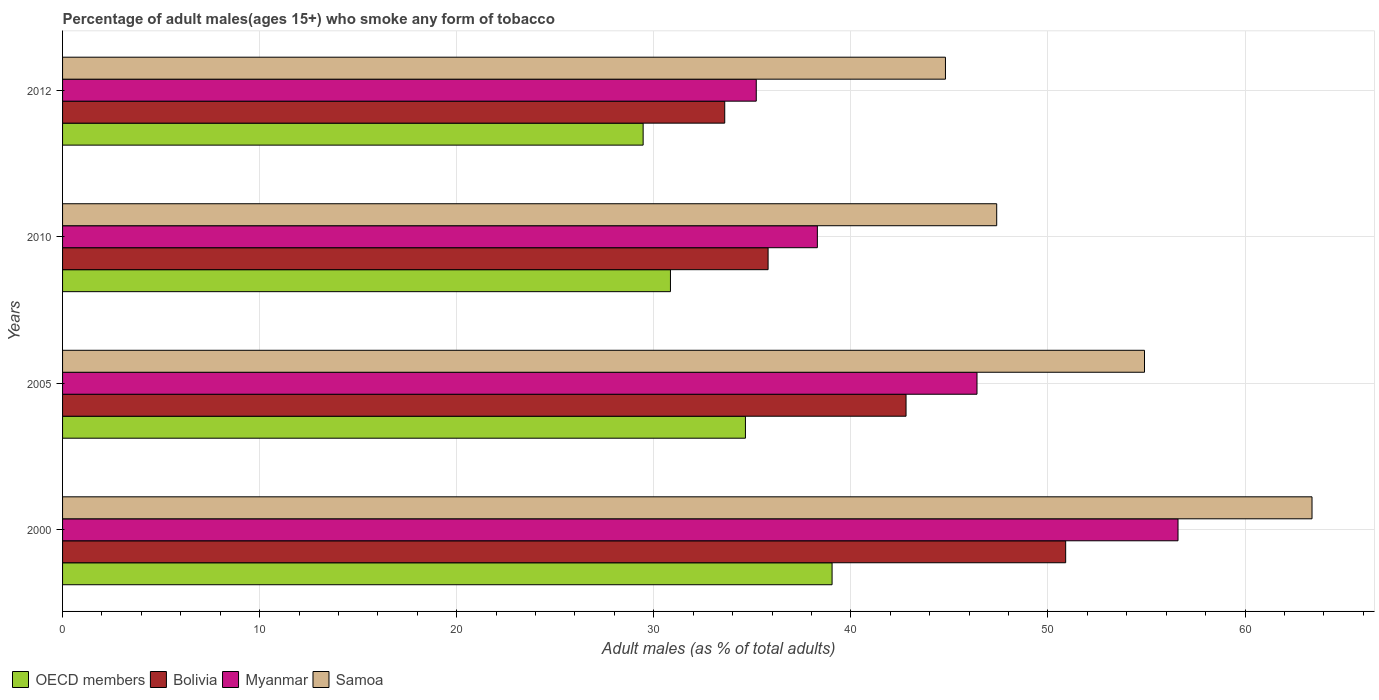Are the number of bars per tick equal to the number of legend labels?
Provide a succinct answer. Yes. Are the number of bars on each tick of the Y-axis equal?
Provide a succinct answer. Yes. How many bars are there on the 4th tick from the bottom?
Your answer should be very brief. 4. What is the label of the 1st group of bars from the top?
Make the answer very short. 2012. What is the percentage of adult males who smoke in OECD members in 2012?
Your answer should be very brief. 29.46. Across all years, what is the maximum percentage of adult males who smoke in Bolivia?
Make the answer very short. 50.9. Across all years, what is the minimum percentage of adult males who smoke in Samoa?
Make the answer very short. 44.8. In which year was the percentage of adult males who smoke in Myanmar maximum?
Offer a terse response. 2000. What is the total percentage of adult males who smoke in Samoa in the graph?
Offer a terse response. 210.5. What is the difference between the percentage of adult males who smoke in Myanmar in 2000 and that in 2005?
Keep it short and to the point. 10.2. What is the difference between the percentage of adult males who smoke in OECD members in 2010 and the percentage of adult males who smoke in Myanmar in 2012?
Your answer should be very brief. -4.35. What is the average percentage of adult males who smoke in OECD members per year?
Your answer should be compact. 33.5. In the year 2012, what is the difference between the percentage of adult males who smoke in OECD members and percentage of adult males who smoke in Myanmar?
Offer a terse response. -5.74. What is the ratio of the percentage of adult males who smoke in Bolivia in 2000 to that in 2010?
Provide a succinct answer. 1.42. Is the difference between the percentage of adult males who smoke in OECD members in 2000 and 2010 greater than the difference between the percentage of adult males who smoke in Myanmar in 2000 and 2010?
Give a very brief answer. No. What is the difference between the highest and the second highest percentage of adult males who smoke in Myanmar?
Make the answer very short. 10.2. What is the difference between the highest and the lowest percentage of adult males who smoke in OECD members?
Provide a short and direct response. 9.59. Is the sum of the percentage of adult males who smoke in Samoa in 2000 and 2005 greater than the maximum percentage of adult males who smoke in Myanmar across all years?
Provide a short and direct response. Yes. What does the 3rd bar from the top in 2012 represents?
Your answer should be very brief. Bolivia. What does the 3rd bar from the bottom in 2000 represents?
Keep it short and to the point. Myanmar. Are all the bars in the graph horizontal?
Make the answer very short. Yes. How many years are there in the graph?
Provide a short and direct response. 4. What is the difference between two consecutive major ticks on the X-axis?
Make the answer very short. 10. Does the graph contain any zero values?
Give a very brief answer. No. Where does the legend appear in the graph?
Your answer should be compact. Bottom left. How many legend labels are there?
Make the answer very short. 4. What is the title of the graph?
Ensure brevity in your answer.  Percentage of adult males(ages 15+) who smoke any form of tobacco. What is the label or title of the X-axis?
Keep it short and to the point. Adult males (as % of total adults). What is the Adult males (as % of total adults) in OECD members in 2000?
Your response must be concise. 39.05. What is the Adult males (as % of total adults) of Bolivia in 2000?
Your response must be concise. 50.9. What is the Adult males (as % of total adults) in Myanmar in 2000?
Your answer should be very brief. 56.6. What is the Adult males (as % of total adults) in Samoa in 2000?
Your answer should be very brief. 63.4. What is the Adult males (as % of total adults) of OECD members in 2005?
Make the answer very short. 34.65. What is the Adult males (as % of total adults) in Bolivia in 2005?
Keep it short and to the point. 42.8. What is the Adult males (as % of total adults) of Myanmar in 2005?
Provide a succinct answer. 46.4. What is the Adult males (as % of total adults) in Samoa in 2005?
Ensure brevity in your answer.  54.9. What is the Adult males (as % of total adults) in OECD members in 2010?
Your answer should be compact. 30.85. What is the Adult males (as % of total adults) in Bolivia in 2010?
Your answer should be compact. 35.8. What is the Adult males (as % of total adults) of Myanmar in 2010?
Your answer should be very brief. 38.3. What is the Adult males (as % of total adults) in Samoa in 2010?
Your answer should be very brief. 47.4. What is the Adult males (as % of total adults) in OECD members in 2012?
Your answer should be compact. 29.46. What is the Adult males (as % of total adults) of Bolivia in 2012?
Your response must be concise. 33.6. What is the Adult males (as % of total adults) of Myanmar in 2012?
Provide a short and direct response. 35.2. What is the Adult males (as % of total adults) in Samoa in 2012?
Make the answer very short. 44.8. Across all years, what is the maximum Adult males (as % of total adults) in OECD members?
Your answer should be compact. 39.05. Across all years, what is the maximum Adult males (as % of total adults) of Bolivia?
Offer a very short reply. 50.9. Across all years, what is the maximum Adult males (as % of total adults) of Myanmar?
Keep it short and to the point. 56.6. Across all years, what is the maximum Adult males (as % of total adults) in Samoa?
Ensure brevity in your answer.  63.4. Across all years, what is the minimum Adult males (as % of total adults) of OECD members?
Offer a terse response. 29.46. Across all years, what is the minimum Adult males (as % of total adults) in Bolivia?
Offer a very short reply. 33.6. Across all years, what is the minimum Adult males (as % of total adults) of Myanmar?
Your answer should be compact. 35.2. Across all years, what is the minimum Adult males (as % of total adults) in Samoa?
Your answer should be very brief. 44.8. What is the total Adult males (as % of total adults) in OECD members in the graph?
Provide a short and direct response. 134. What is the total Adult males (as % of total adults) of Bolivia in the graph?
Offer a terse response. 163.1. What is the total Adult males (as % of total adults) in Myanmar in the graph?
Provide a short and direct response. 176.5. What is the total Adult males (as % of total adults) in Samoa in the graph?
Your answer should be very brief. 210.5. What is the difference between the Adult males (as % of total adults) in OECD members in 2000 and that in 2005?
Provide a short and direct response. 4.4. What is the difference between the Adult males (as % of total adults) of Myanmar in 2000 and that in 2005?
Ensure brevity in your answer.  10.2. What is the difference between the Adult males (as % of total adults) in OECD members in 2000 and that in 2010?
Offer a very short reply. 8.2. What is the difference between the Adult males (as % of total adults) in Bolivia in 2000 and that in 2010?
Provide a short and direct response. 15.1. What is the difference between the Adult males (as % of total adults) in Samoa in 2000 and that in 2010?
Provide a short and direct response. 16. What is the difference between the Adult males (as % of total adults) of OECD members in 2000 and that in 2012?
Keep it short and to the point. 9.59. What is the difference between the Adult males (as % of total adults) of Bolivia in 2000 and that in 2012?
Keep it short and to the point. 17.3. What is the difference between the Adult males (as % of total adults) in Myanmar in 2000 and that in 2012?
Your answer should be compact. 21.4. What is the difference between the Adult males (as % of total adults) of Samoa in 2000 and that in 2012?
Ensure brevity in your answer.  18.6. What is the difference between the Adult males (as % of total adults) of OECD members in 2005 and that in 2010?
Ensure brevity in your answer.  3.81. What is the difference between the Adult males (as % of total adults) of Myanmar in 2005 and that in 2010?
Make the answer very short. 8.1. What is the difference between the Adult males (as % of total adults) in Samoa in 2005 and that in 2010?
Offer a very short reply. 7.5. What is the difference between the Adult males (as % of total adults) of OECD members in 2005 and that in 2012?
Your answer should be compact. 5.19. What is the difference between the Adult males (as % of total adults) of Bolivia in 2005 and that in 2012?
Your response must be concise. 9.2. What is the difference between the Adult males (as % of total adults) in Samoa in 2005 and that in 2012?
Make the answer very short. 10.1. What is the difference between the Adult males (as % of total adults) of OECD members in 2010 and that in 2012?
Offer a terse response. 1.39. What is the difference between the Adult males (as % of total adults) of Samoa in 2010 and that in 2012?
Make the answer very short. 2.6. What is the difference between the Adult males (as % of total adults) of OECD members in 2000 and the Adult males (as % of total adults) of Bolivia in 2005?
Offer a very short reply. -3.75. What is the difference between the Adult males (as % of total adults) of OECD members in 2000 and the Adult males (as % of total adults) of Myanmar in 2005?
Make the answer very short. -7.35. What is the difference between the Adult males (as % of total adults) in OECD members in 2000 and the Adult males (as % of total adults) in Samoa in 2005?
Provide a short and direct response. -15.85. What is the difference between the Adult males (as % of total adults) of Bolivia in 2000 and the Adult males (as % of total adults) of Myanmar in 2005?
Offer a very short reply. 4.5. What is the difference between the Adult males (as % of total adults) in Myanmar in 2000 and the Adult males (as % of total adults) in Samoa in 2005?
Ensure brevity in your answer.  1.7. What is the difference between the Adult males (as % of total adults) in OECD members in 2000 and the Adult males (as % of total adults) in Bolivia in 2010?
Provide a short and direct response. 3.25. What is the difference between the Adult males (as % of total adults) in OECD members in 2000 and the Adult males (as % of total adults) in Myanmar in 2010?
Make the answer very short. 0.75. What is the difference between the Adult males (as % of total adults) of OECD members in 2000 and the Adult males (as % of total adults) of Samoa in 2010?
Keep it short and to the point. -8.35. What is the difference between the Adult males (as % of total adults) of Bolivia in 2000 and the Adult males (as % of total adults) of Myanmar in 2010?
Offer a very short reply. 12.6. What is the difference between the Adult males (as % of total adults) in Bolivia in 2000 and the Adult males (as % of total adults) in Samoa in 2010?
Provide a succinct answer. 3.5. What is the difference between the Adult males (as % of total adults) in OECD members in 2000 and the Adult males (as % of total adults) in Bolivia in 2012?
Keep it short and to the point. 5.45. What is the difference between the Adult males (as % of total adults) of OECD members in 2000 and the Adult males (as % of total adults) of Myanmar in 2012?
Provide a succinct answer. 3.85. What is the difference between the Adult males (as % of total adults) in OECD members in 2000 and the Adult males (as % of total adults) in Samoa in 2012?
Provide a succinct answer. -5.75. What is the difference between the Adult males (as % of total adults) in Bolivia in 2000 and the Adult males (as % of total adults) in Myanmar in 2012?
Keep it short and to the point. 15.7. What is the difference between the Adult males (as % of total adults) of Bolivia in 2000 and the Adult males (as % of total adults) of Samoa in 2012?
Your answer should be very brief. 6.1. What is the difference between the Adult males (as % of total adults) of OECD members in 2005 and the Adult males (as % of total adults) of Bolivia in 2010?
Offer a very short reply. -1.15. What is the difference between the Adult males (as % of total adults) in OECD members in 2005 and the Adult males (as % of total adults) in Myanmar in 2010?
Give a very brief answer. -3.65. What is the difference between the Adult males (as % of total adults) of OECD members in 2005 and the Adult males (as % of total adults) of Samoa in 2010?
Provide a short and direct response. -12.75. What is the difference between the Adult males (as % of total adults) in OECD members in 2005 and the Adult males (as % of total adults) in Bolivia in 2012?
Provide a succinct answer. 1.05. What is the difference between the Adult males (as % of total adults) of OECD members in 2005 and the Adult males (as % of total adults) of Myanmar in 2012?
Provide a short and direct response. -0.55. What is the difference between the Adult males (as % of total adults) of OECD members in 2005 and the Adult males (as % of total adults) of Samoa in 2012?
Your response must be concise. -10.15. What is the difference between the Adult males (as % of total adults) of OECD members in 2010 and the Adult males (as % of total adults) of Bolivia in 2012?
Keep it short and to the point. -2.75. What is the difference between the Adult males (as % of total adults) in OECD members in 2010 and the Adult males (as % of total adults) in Myanmar in 2012?
Provide a succinct answer. -4.35. What is the difference between the Adult males (as % of total adults) in OECD members in 2010 and the Adult males (as % of total adults) in Samoa in 2012?
Offer a terse response. -13.95. What is the difference between the Adult males (as % of total adults) in Bolivia in 2010 and the Adult males (as % of total adults) in Samoa in 2012?
Offer a very short reply. -9. What is the difference between the Adult males (as % of total adults) in Myanmar in 2010 and the Adult males (as % of total adults) in Samoa in 2012?
Your response must be concise. -6.5. What is the average Adult males (as % of total adults) of OECD members per year?
Ensure brevity in your answer.  33.5. What is the average Adult males (as % of total adults) of Bolivia per year?
Ensure brevity in your answer.  40.77. What is the average Adult males (as % of total adults) of Myanmar per year?
Offer a terse response. 44.12. What is the average Adult males (as % of total adults) in Samoa per year?
Ensure brevity in your answer.  52.62. In the year 2000, what is the difference between the Adult males (as % of total adults) of OECD members and Adult males (as % of total adults) of Bolivia?
Your answer should be very brief. -11.85. In the year 2000, what is the difference between the Adult males (as % of total adults) of OECD members and Adult males (as % of total adults) of Myanmar?
Give a very brief answer. -17.55. In the year 2000, what is the difference between the Adult males (as % of total adults) in OECD members and Adult males (as % of total adults) in Samoa?
Make the answer very short. -24.35. In the year 2005, what is the difference between the Adult males (as % of total adults) in OECD members and Adult males (as % of total adults) in Bolivia?
Keep it short and to the point. -8.15. In the year 2005, what is the difference between the Adult males (as % of total adults) in OECD members and Adult males (as % of total adults) in Myanmar?
Offer a terse response. -11.75. In the year 2005, what is the difference between the Adult males (as % of total adults) of OECD members and Adult males (as % of total adults) of Samoa?
Your answer should be compact. -20.25. In the year 2005, what is the difference between the Adult males (as % of total adults) of Bolivia and Adult males (as % of total adults) of Myanmar?
Provide a short and direct response. -3.6. In the year 2005, what is the difference between the Adult males (as % of total adults) in Bolivia and Adult males (as % of total adults) in Samoa?
Your response must be concise. -12.1. In the year 2005, what is the difference between the Adult males (as % of total adults) in Myanmar and Adult males (as % of total adults) in Samoa?
Offer a very short reply. -8.5. In the year 2010, what is the difference between the Adult males (as % of total adults) of OECD members and Adult males (as % of total adults) of Bolivia?
Provide a short and direct response. -4.95. In the year 2010, what is the difference between the Adult males (as % of total adults) of OECD members and Adult males (as % of total adults) of Myanmar?
Provide a succinct answer. -7.45. In the year 2010, what is the difference between the Adult males (as % of total adults) in OECD members and Adult males (as % of total adults) in Samoa?
Keep it short and to the point. -16.55. In the year 2010, what is the difference between the Adult males (as % of total adults) in Bolivia and Adult males (as % of total adults) in Samoa?
Provide a succinct answer. -11.6. In the year 2012, what is the difference between the Adult males (as % of total adults) of OECD members and Adult males (as % of total adults) of Bolivia?
Offer a very short reply. -4.14. In the year 2012, what is the difference between the Adult males (as % of total adults) in OECD members and Adult males (as % of total adults) in Myanmar?
Make the answer very short. -5.74. In the year 2012, what is the difference between the Adult males (as % of total adults) of OECD members and Adult males (as % of total adults) of Samoa?
Give a very brief answer. -15.34. What is the ratio of the Adult males (as % of total adults) in OECD members in 2000 to that in 2005?
Provide a short and direct response. 1.13. What is the ratio of the Adult males (as % of total adults) of Bolivia in 2000 to that in 2005?
Make the answer very short. 1.19. What is the ratio of the Adult males (as % of total adults) in Myanmar in 2000 to that in 2005?
Give a very brief answer. 1.22. What is the ratio of the Adult males (as % of total adults) in Samoa in 2000 to that in 2005?
Keep it short and to the point. 1.15. What is the ratio of the Adult males (as % of total adults) in OECD members in 2000 to that in 2010?
Provide a succinct answer. 1.27. What is the ratio of the Adult males (as % of total adults) of Bolivia in 2000 to that in 2010?
Give a very brief answer. 1.42. What is the ratio of the Adult males (as % of total adults) of Myanmar in 2000 to that in 2010?
Give a very brief answer. 1.48. What is the ratio of the Adult males (as % of total adults) of Samoa in 2000 to that in 2010?
Ensure brevity in your answer.  1.34. What is the ratio of the Adult males (as % of total adults) in OECD members in 2000 to that in 2012?
Offer a very short reply. 1.33. What is the ratio of the Adult males (as % of total adults) in Bolivia in 2000 to that in 2012?
Offer a terse response. 1.51. What is the ratio of the Adult males (as % of total adults) of Myanmar in 2000 to that in 2012?
Your answer should be compact. 1.61. What is the ratio of the Adult males (as % of total adults) in Samoa in 2000 to that in 2012?
Provide a succinct answer. 1.42. What is the ratio of the Adult males (as % of total adults) in OECD members in 2005 to that in 2010?
Keep it short and to the point. 1.12. What is the ratio of the Adult males (as % of total adults) in Bolivia in 2005 to that in 2010?
Offer a terse response. 1.2. What is the ratio of the Adult males (as % of total adults) in Myanmar in 2005 to that in 2010?
Your answer should be very brief. 1.21. What is the ratio of the Adult males (as % of total adults) in Samoa in 2005 to that in 2010?
Provide a short and direct response. 1.16. What is the ratio of the Adult males (as % of total adults) in OECD members in 2005 to that in 2012?
Provide a succinct answer. 1.18. What is the ratio of the Adult males (as % of total adults) in Bolivia in 2005 to that in 2012?
Your response must be concise. 1.27. What is the ratio of the Adult males (as % of total adults) of Myanmar in 2005 to that in 2012?
Provide a succinct answer. 1.32. What is the ratio of the Adult males (as % of total adults) in Samoa in 2005 to that in 2012?
Provide a succinct answer. 1.23. What is the ratio of the Adult males (as % of total adults) of OECD members in 2010 to that in 2012?
Your answer should be very brief. 1.05. What is the ratio of the Adult males (as % of total adults) in Bolivia in 2010 to that in 2012?
Provide a short and direct response. 1.07. What is the ratio of the Adult males (as % of total adults) of Myanmar in 2010 to that in 2012?
Give a very brief answer. 1.09. What is the ratio of the Adult males (as % of total adults) in Samoa in 2010 to that in 2012?
Provide a succinct answer. 1.06. What is the difference between the highest and the second highest Adult males (as % of total adults) in OECD members?
Offer a terse response. 4.4. What is the difference between the highest and the lowest Adult males (as % of total adults) of OECD members?
Your answer should be very brief. 9.59. What is the difference between the highest and the lowest Adult males (as % of total adults) in Bolivia?
Make the answer very short. 17.3. What is the difference between the highest and the lowest Adult males (as % of total adults) in Myanmar?
Provide a short and direct response. 21.4. What is the difference between the highest and the lowest Adult males (as % of total adults) in Samoa?
Make the answer very short. 18.6. 